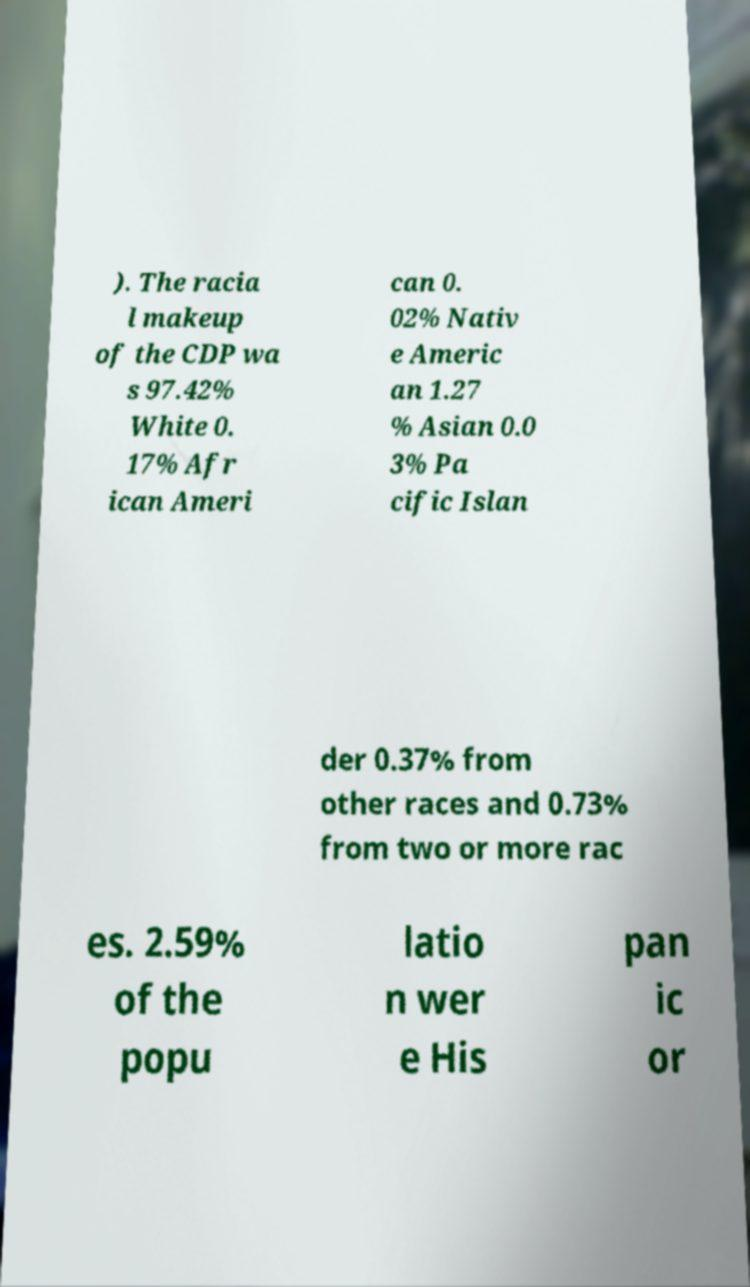What messages or text are displayed in this image? I need them in a readable, typed format. ). The racia l makeup of the CDP wa s 97.42% White 0. 17% Afr ican Ameri can 0. 02% Nativ e Americ an 1.27 % Asian 0.0 3% Pa cific Islan der 0.37% from other races and 0.73% from two or more rac es. 2.59% of the popu latio n wer e His pan ic or 